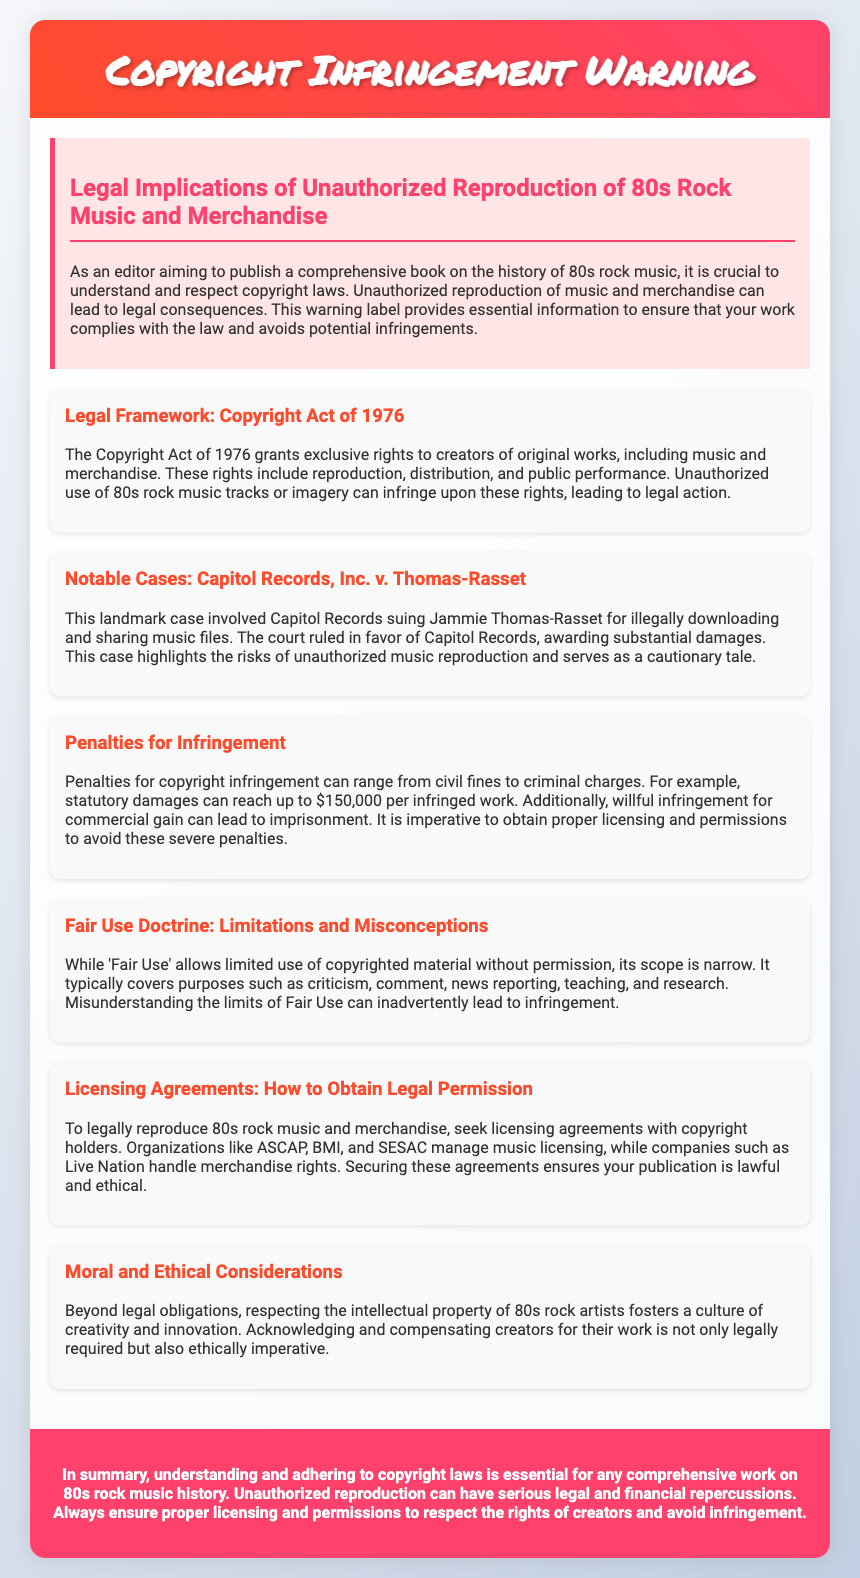What is the title of the document? The title is displayed in the header section of the document and indicates the main topic addressed.
Answer: Copyright Infringement Warning What legal framework governs copyright issues? The document cites a specific act that provides the legal basis for copyright protections.
Answer: Copyright Act of 1976 What case is used as an example of copyright infringement? A notable legal case is mentioned within the document to illustrate the risks involved in unauthorized reproduction.
Answer: Capitol Records, Inc. v. Thomas-Rasset What is the maximum statutory damage per infringed work? The document specifically mentions a potential financial repercussion for infringement that can be quite substantial.
Answer: $150,000 What organization is mentioned for music licensing? The document lists specific organizations that are involved in the process of music licensing.
Answer: ASCAP What is the primary purpose of the Fair Use Doctrine? The section on Fair Use describes the circumstances under which limited reproduction of copyrighted material may be allowed.
Answer: Limited use What should one obtain to legally reproduce 80s rock music? The document emphasizes the need for a specific type of agreement to ensure lawful reproduction of music.
Answer: Licensing agreements Why is it important to respect the intellectual property of artists? The document addresses both legal and personal responsibilities towards creators within a specific cultural context.
Answer: Ethical imperative What is the hallmark of unauthorized reproduction highlighted in the document? The warning label stresses a significant potential consequence for unauthorized actions relating to music and merchandise.
Answer: Legal consequences 